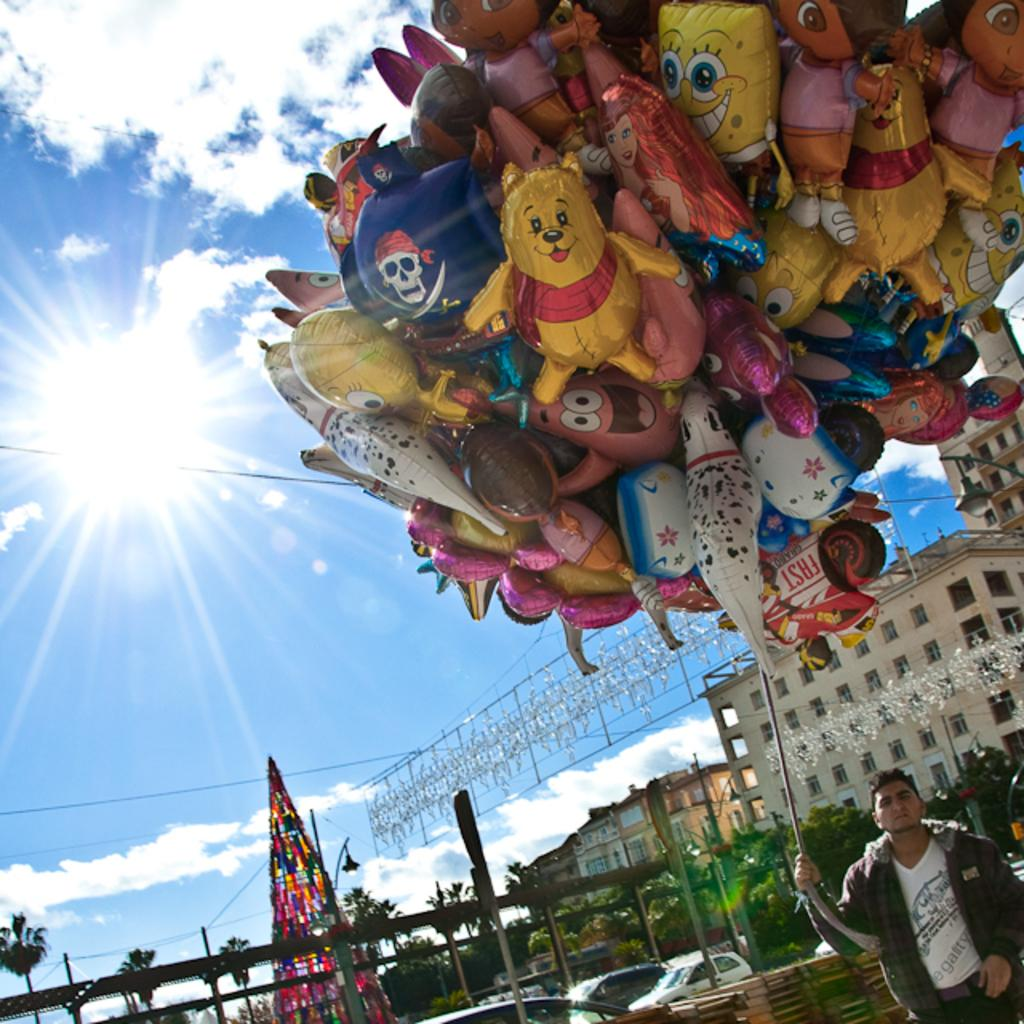What type of structures can be seen in the image? There are buildings in the image. What other natural elements are present in the image? There are trees in the image. What mode of transportation can be seen in the image? Cars are parked in the image. How would you describe the weather in the image? The sky is blue and cloudy, and sunlight is visible, suggesting a partly cloudy day. What is the man in the image doing? The man is holding balloons with the help of a rope. Can you tell me how many mittens the man is wearing in the image? There are no mittens present in the image; the man is holding balloons with a rope. What is the man's desire for the balloons in the image? The image does not provide information about the man's desires or intentions regarding the balloons. 